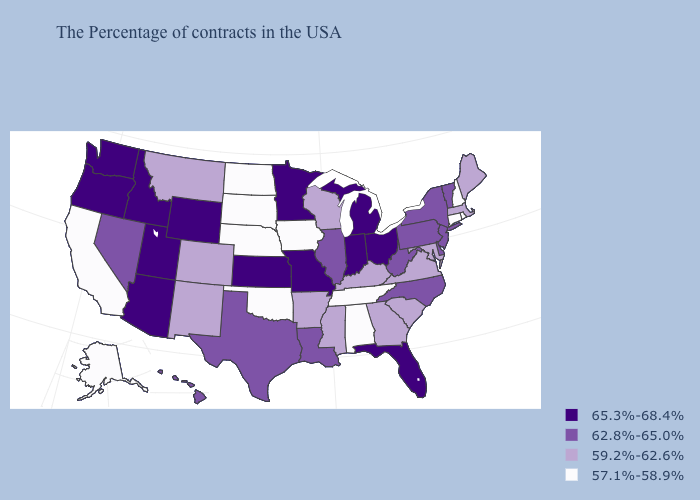What is the value of Pennsylvania?
Short answer required. 62.8%-65.0%. What is the lowest value in states that border Pennsylvania?
Give a very brief answer. 59.2%-62.6%. Does Michigan have a higher value than Minnesota?
Be succinct. No. What is the value of Michigan?
Answer briefly. 65.3%-68.4%. What is the highest value in the USA?
Concise answer only. 65.3%-68.4%. Which states have the highest value in the USA?
Short answer required. Ohio, Florida, Michigan, Indiana, Missouri, Minnesota, Kansas, Wyoming, Utah, Arizona, Idaho, Washington, Oregon. Does Alabama have the lowest value in the USA?
Give a very brief answer. Yes. Among the states that border Iowa , does Missouri have the highest value?
Be succinct. Yes. Which states have the lowest value in the USA?
Quick response, please. Rhode Island, New Hampshire, Connecticut, Alabama, Tennessee, Iowa, Nebraska, Oklahoma, South Dakota, North Dakota, California, Alaska. What is the value of Montana?
Short answer required. 59.2%-62.6%. What is the highest value in the South ?
Give a very brief answer. 65.3%-68.4%. Among the states that border Tennessee , which have the highest value?
Be succinct. Missouri. What is the value of New Hampshire?
Answer briefly. 57.1%-58.9%. Does Arizona have the lowest value in the USA?
Quick response, please. No. Name the states that have a value in the range 65.3%-68.4%?
Keep it brief. Ohio, Florida, Michigan, Indiana, Missouri, Minnesota, Kansas, Wyoming, Utah, Arizona, Idaho, Washington, Oregon. 